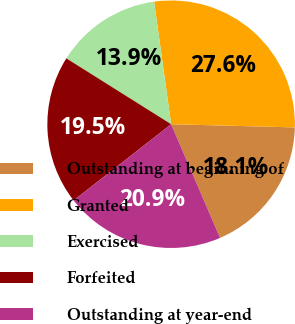Convert chart. <chart><loc_0><loc_0><loc_500><loc_500><pie_chart><fcel>Outstanding at beginning of<fcel>Granted<fcel>Exercised<fcel>Forfeited<fcel>Outstanding at year-end<nl><fcel>18.12%<fcel>27.61%<fcel>13.87%<fcel>19.49%<fcel>20.91%<nl></chart> 